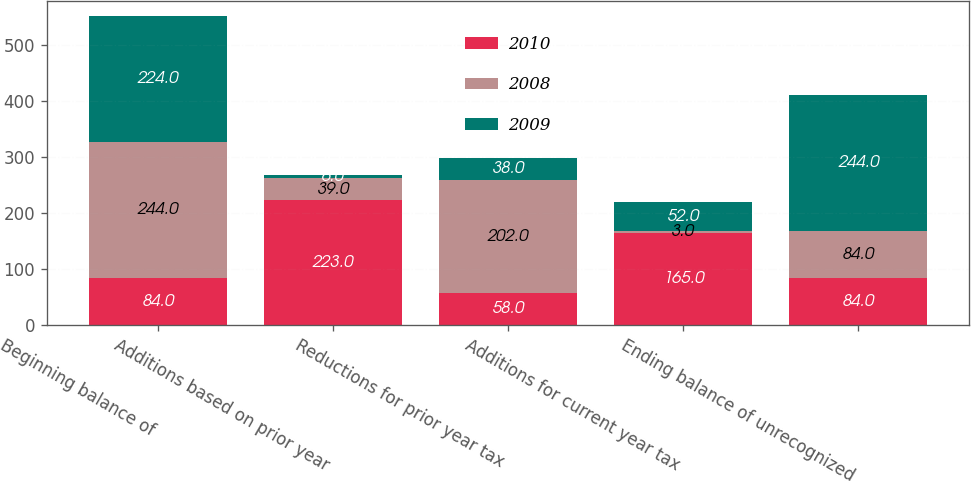Convert chart. <chart><loc_0><loc_0><loc_500><loc_500><stacked_bar_chart><ecel><fcel>Beginning balance of<fcel>Additions based on prior year<fcel>Reductions for prior year tax<fcel>Additions for current year tax<fcel>Ending balance of unrecognized<nl><fcel>2010<fcel>84<fcel>223<fcel>58<fcel>165<fcel>84<nl><fcel>2008<fcel>244<fcel>39<fcel>202<fcel>3<fcel>84<nl><fcel>2009<fcel>224<fcel>6<fcel>38<fcel>52<fcel>244<nl></chart> 